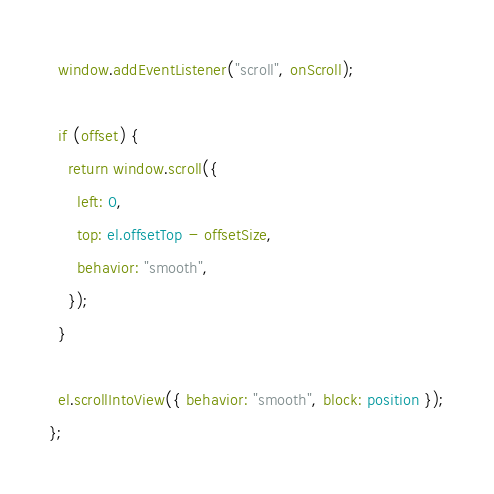Convert code to text. <code><loc_0><loc_0><loc_500><loc_500><_TypeScript_>  window.addEventListener("scroll", onScroll);

  if (offset) {
    return window.scroll({
      left: 0,
      top: el.offsetTop - offsetSize,
      behavior: "smooth",
    });
  }

  el.scrollIntoView({ behavior: "smooth", block: position });
};
</code> 